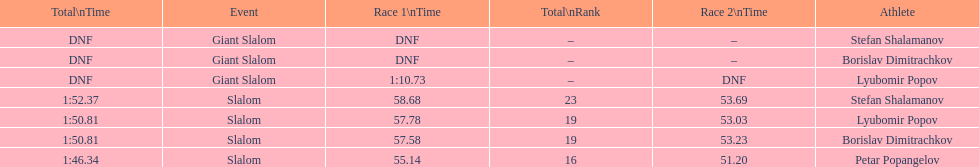What is the number of athletes to finish race one in the giant slalom? 1. 